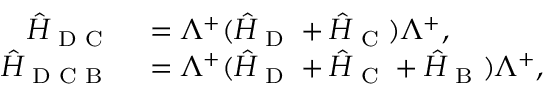<formula> <loc_0><loc_0><loc_500><loc_500>\begin{array} { r l } { \hat { H } _ { D C } } & = \Lambda ^ { + } ( \hat { H } _ { D } + \hat { H } _ { C } ) \Lambda ^ { + } , } \\ { \hat { H } _ { D C B } } & = \Lambda ^ { + } ( \hat { H } _ { D } + \hat { H } _ { C } + \hat { H } _ { B } ) \Lambda ^ { + } , } \end{array}</formula> 